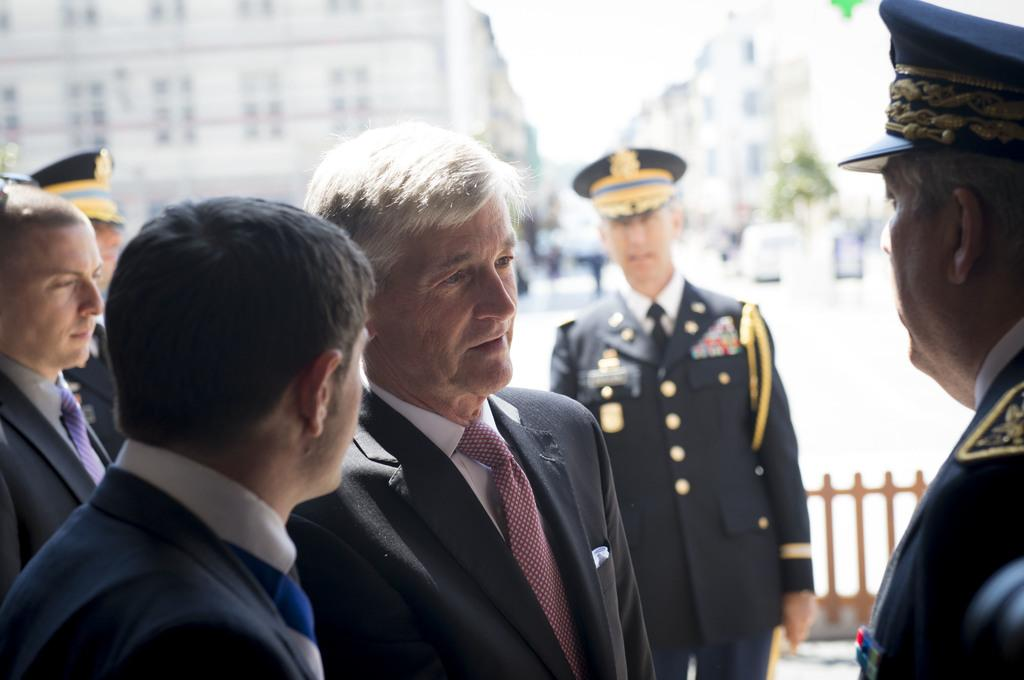Who or what can be seen in the image? There are people in the image. What are the people wearing in the image? The people are wearing jackets and caps. What can be seen in the background of the image? There is a fence in the background of the image. What type of sea creature can be seen swimming near the people in the image? There is no sea creature present in the image; it features people wearing jackets and caps with a fence in the background. 